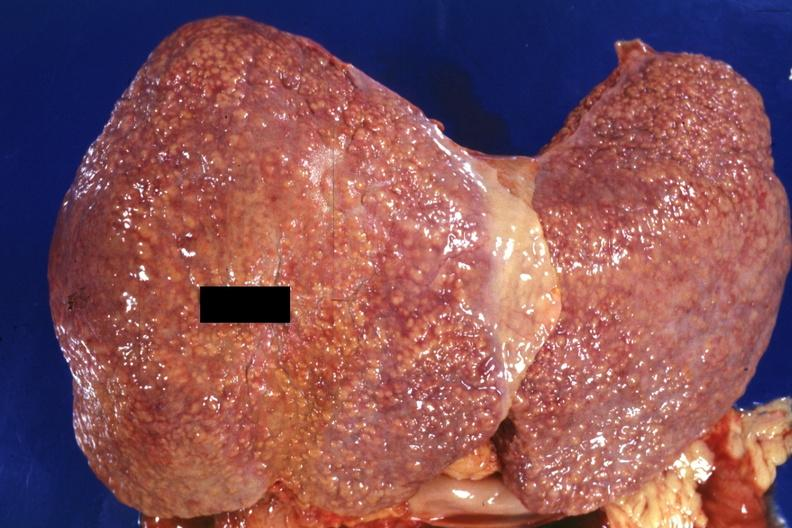does malignant lymphoma show external view of large liver with obvious cirrhosis excellent example?
Answer the question using a single word or phrase. No 